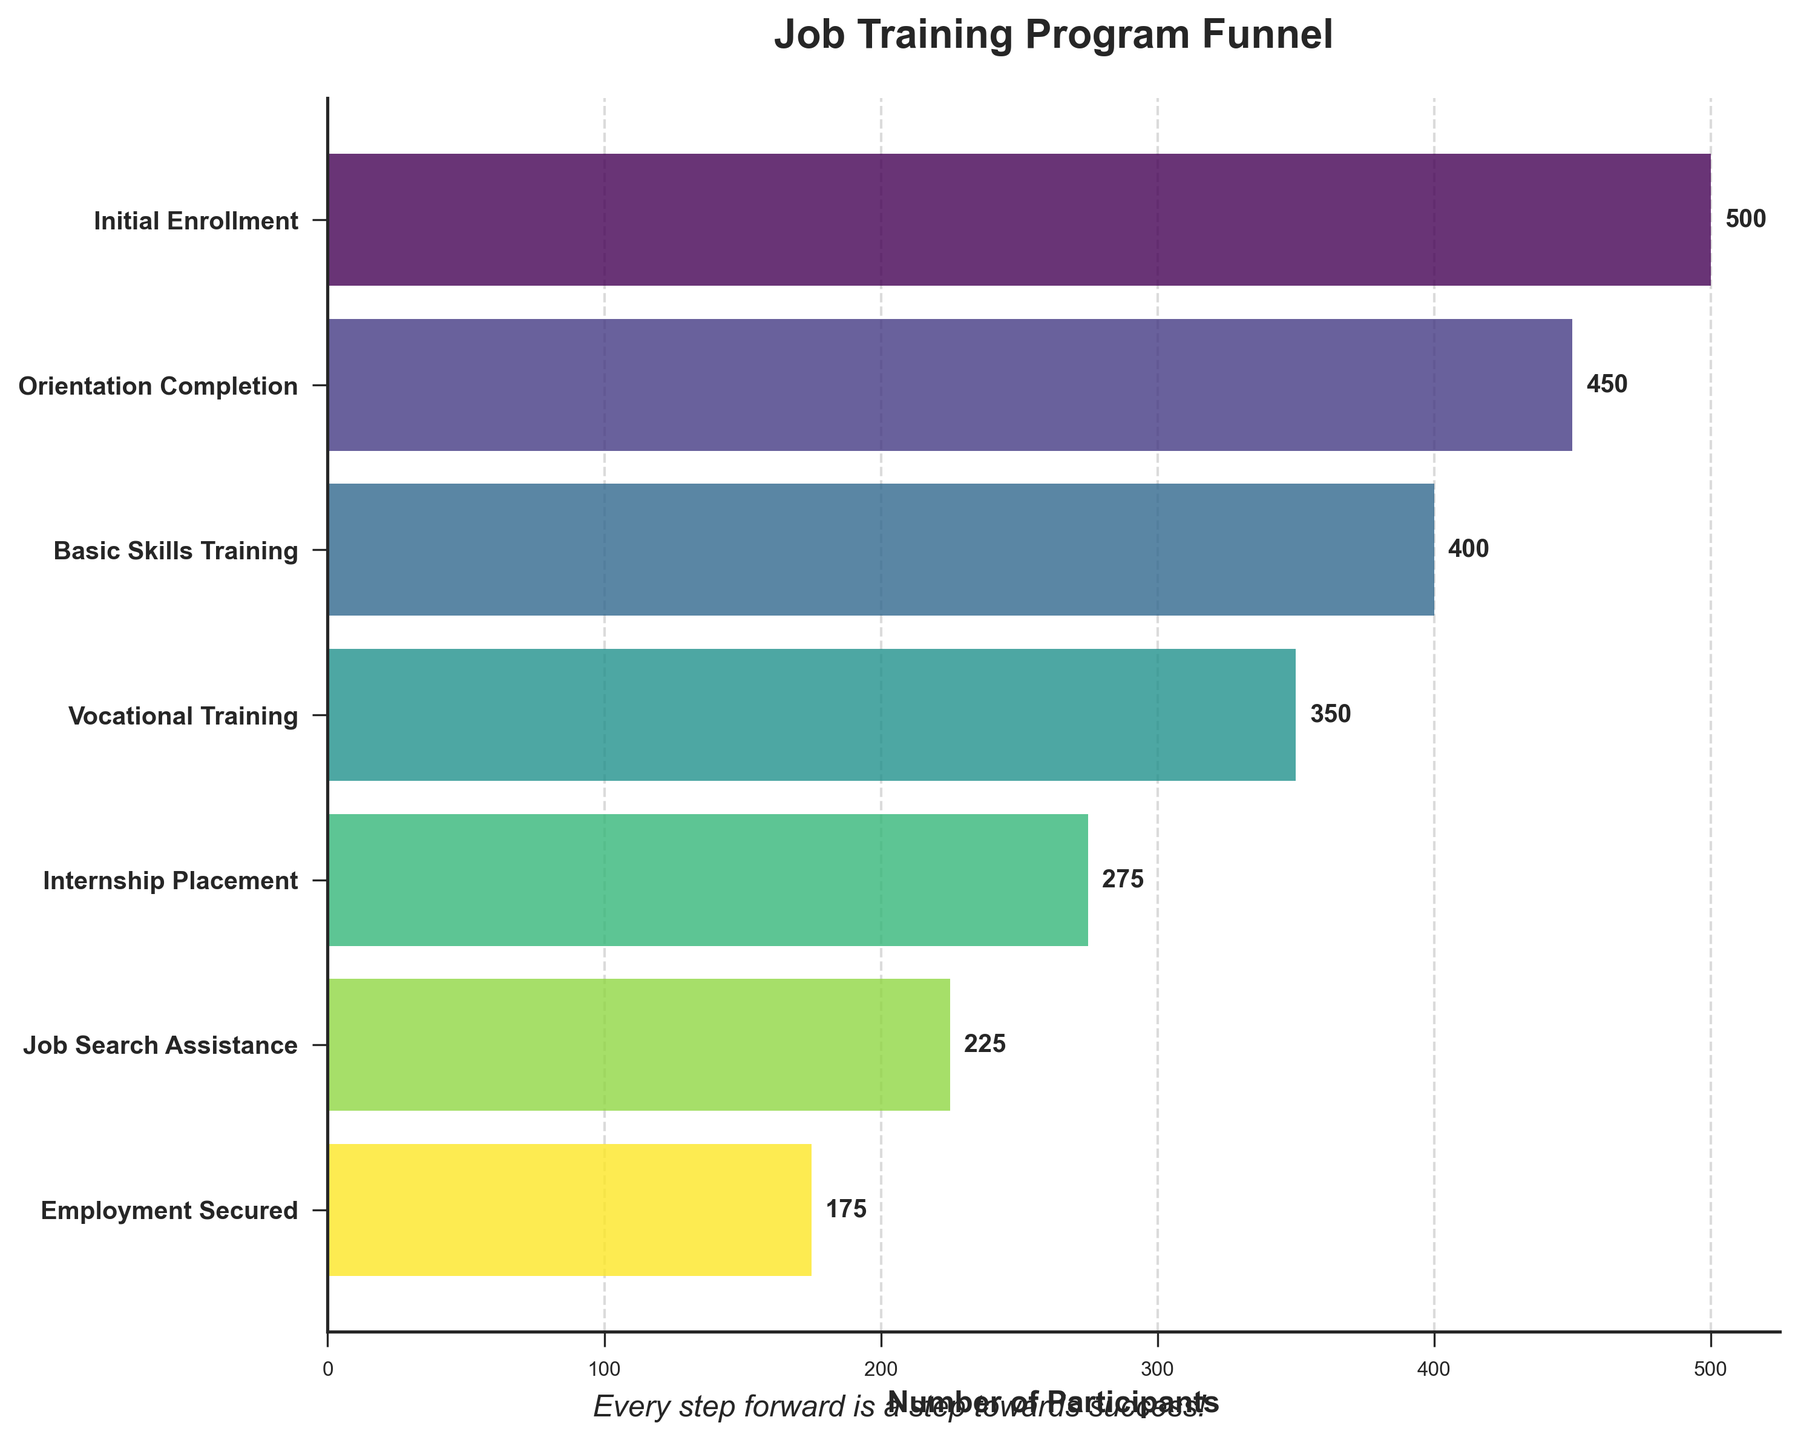what is the title of the figure? The title of the figure is displayed at the top and summarizes the overall theme of the chart. Here, it states "Job Training Program Funnel", clearly indicating the content.
Answer: Job Training Program Funnel How many stages are depicted in the funnel chart? The funnel chart displays each stage on the y-axis. By counting the labels, we can see how many there are. There are 7 stages shown.
Answer: 7 What is the number of participants at the "Internship Placement" stage? Look for the "Internship Placement" label on the y-axis and then check the number indicated at the end of the corresponding bar. The number is 275.
Answer: 275 How many more participants are there in the "Basic Skills Training" stage compared to the "Job Search Assistance" stage? Identify the participant numbers for both stages ("Basic Skills Training" has 400, and "Job Search Assistance" has 225). Subtract the second number from the first (400 - 225).
Answer: 175 What percentage of participants who completed "Basic Skills Training" ended up securing employment? The number of participants in "Basic Skills Training" is 400. The number of participants who secured employment is 175. To find the percentage, divide 175 by 400 and then multiply by 100. (175 / 400) * 100 = 43.75%
Answer: 43.75% Which stage has the highest drop-off in participant count compared to the previous stage? Look at the differences in participant counts between each consecutive stage. Calculate the differences: 500-450=50, 450-400=50, 400-350=50, 350-275=75, 275-225=50, 225-175=50. The highest drop-off is between "Vocational Training" and "Internship Placement" with 75 participants.
Answer: Vocational Training to Internship Placement By how much does the number of participants decrease from "Orientation Completion" to "Employment Secured"? Find the participant numbers at both stages. "Orientation Completion" has 450 participants, and "Employment Secured" has 175 participants. Subtract the latter from the former (450 - 175).
Answer: 275 What is the ratio of "Job Search Assistance" participants to "Initial Enrollment" participants? Find the participant numbers at both stages: "Job Search Assistance" has 225 participants, and "Initial Enrollment" has 500 participants. Divide 225 by 500 to find the ratio. 225 / 500 = 0.45
Answer: 0.45 What phrase is included as a motivational quote in the figure? The motivational quote is positioned at the bottom of the figure, providing encouragement to the viewers. The quote reads, "Every step forward is a step towards success!"
Answer: Every step forward is a step towards success! 